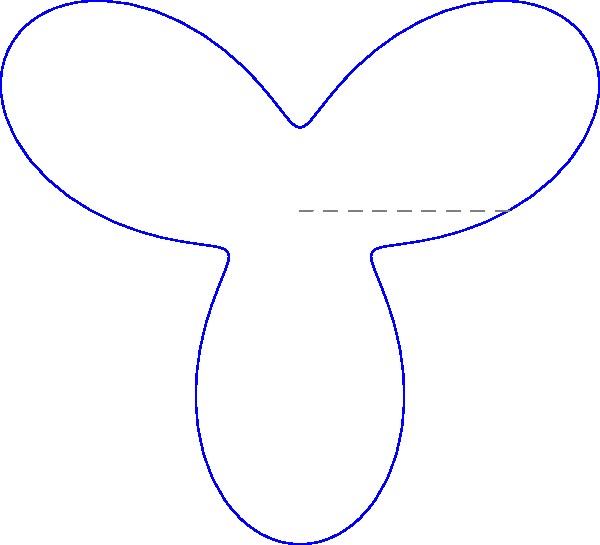The polar curve $r = 5 + 3\sin(3\theta)$ is used to visualize the adoption rates of various technologies in different sectors. Each "petal" represents a technology, and its length indicates the adoption rate. Which technology shows the highest adoption rate, and what characteristic of the curve determines this? To solve this problem, we need to follow these steps:

1) Understand the polar curve equation: $r = 5 + 3\sin(3\theta)$
   - The base radius is 5 units
   - The amplitude of the sinusoidal variation is 3 units
   - There are 3 full cycles (petals) in the $2\pi$ range due to $3\theta$

2) Identify the technologies represented:
   - The six petals represent Social Media, E-commerce, Cloud Computing, IoT, AI, and Blockchain

3) Determine what indicates high adoption:
   - Longer petals indicate higher adoption rates

4) Find the maximum value of $r$:
   - The maximum occurs when $\sin(3\theta) = 1$
   - $r_{max} = 5 + 3(1) = 8$

5) Locate the longest petals:
   - The longest petals reach the outermost circle (radius 8)
   - These correspond to Social Media and IoT

6) Identify the curve characteristic:
   - The length of each petal is determined by the maximum value of $r$ in that direction
   - This maximum occurs when $\sin(3\theta)$ reaches its peak value of 1

Therefore, Social Media and IoT show the highest adoption rates, and this is determined by the maximum radial distance (r) of the curve in those directions.
Answer: Social Media and IoT; maximum radial distance 